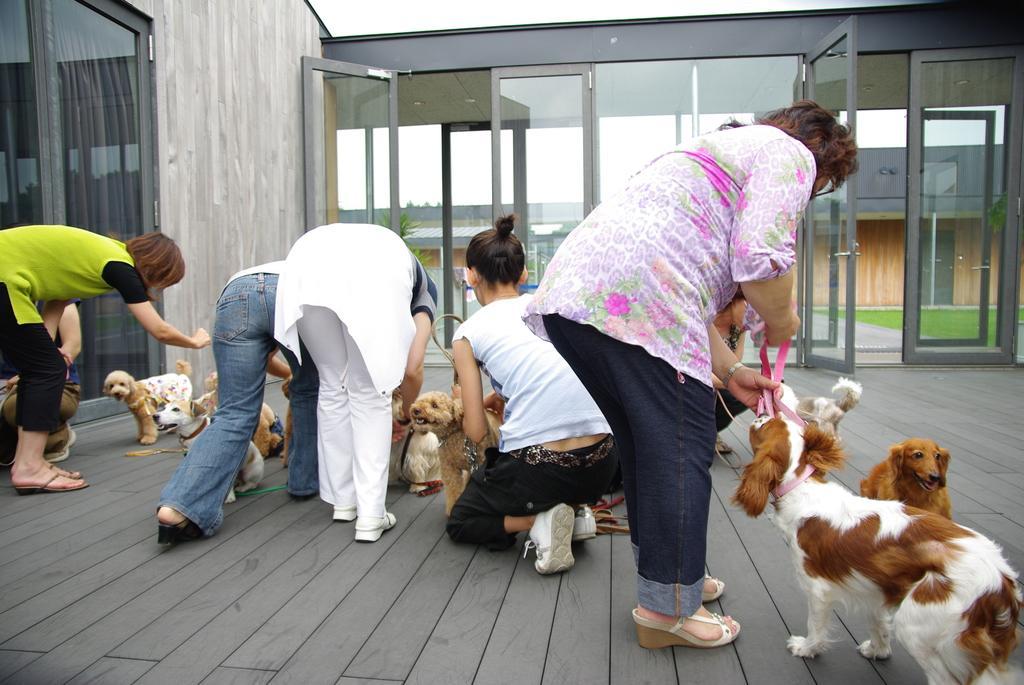Describe this image in one or two sentences. In the image there are few women leaning forward holding dogs on the wooden floor and in the back there are glass walls. 